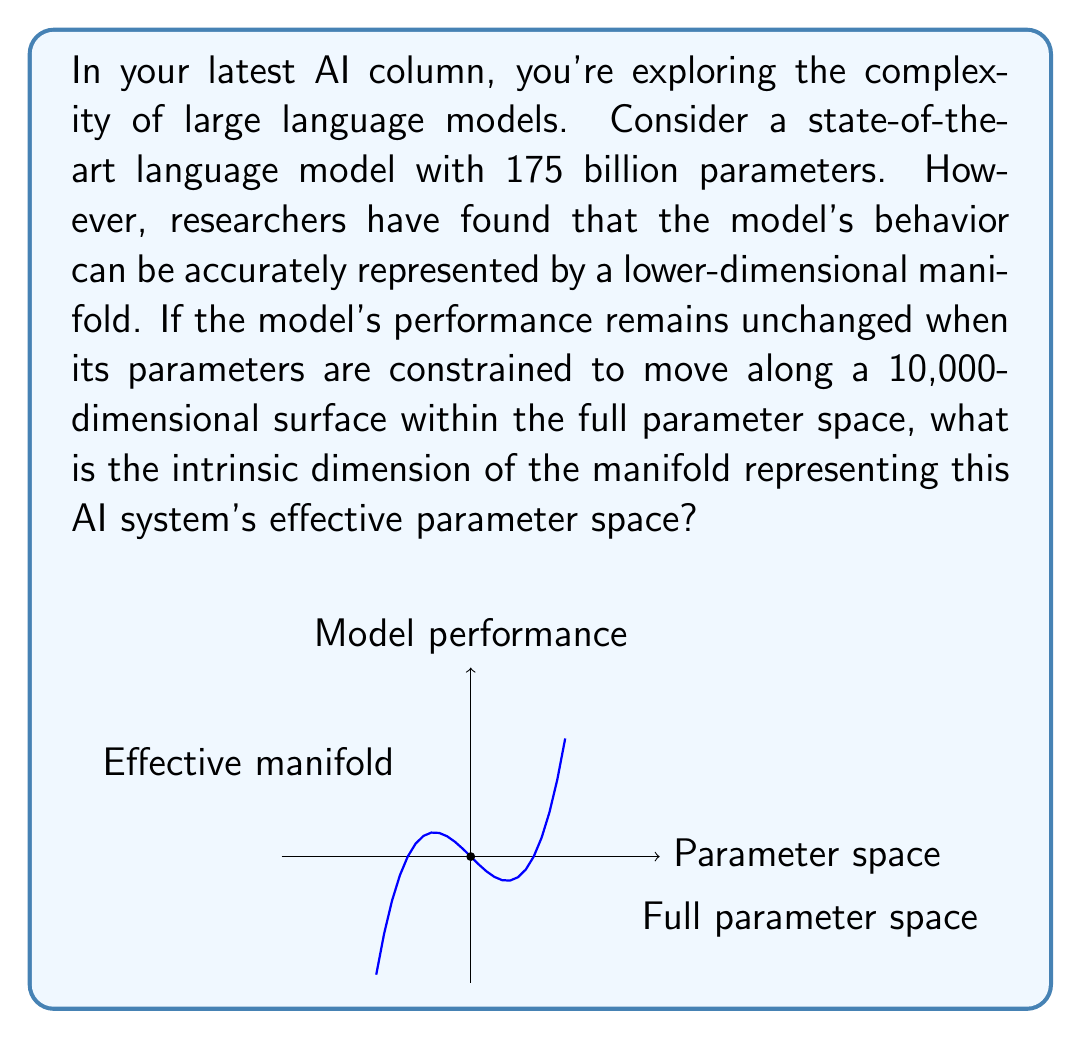Could you help me with this problem? To determine the intrinsic dimension of the manifold representing the AI system's parameter space, we need to understand a few key concepts:

1. Parameter space: The full space of all possible parameter configurations for the model. In this case, it's 175 billion dimensions.

2. Intrinsic dimension: The minimum number of parameters needed to represent the model's behavior without loss of performance.

3. Manifold: A topological space that locally resembles Euclidean space. In this context, it's a lower-dimensional surface within the full parameter space where the model's behavior is effectively constrained.

Now, let's analyze the given information:

1. The model has 175 billion parameters originally, so the full parameter space is $$\mathbb{R}^{175,000,000,000}$$.

2. The model's behavior can be accurately represented by a lower-dimensional manifold.

3. The model's performance remains unchanged when its parameters are constrained to move along a 10,000-dimensional surface.

The key insight is that the intrinsic dimension of the manifold is equal to the dimension of the surface on which the model's parameters can move without affecting its performance. This is because this surface captures all the essential degrees of freedom needed to represent the model's behavior.

Therefore, the intrinsic dimension of the manifold representing this AI system's effective parameter space is 10,000.

This result demonstrates a significant reduction in complexity from the original 175 billion parameters to an effective 10,000-dimensional space, highlighting the efficiency and potential for compression in large AI models.
Answer: 10,000 